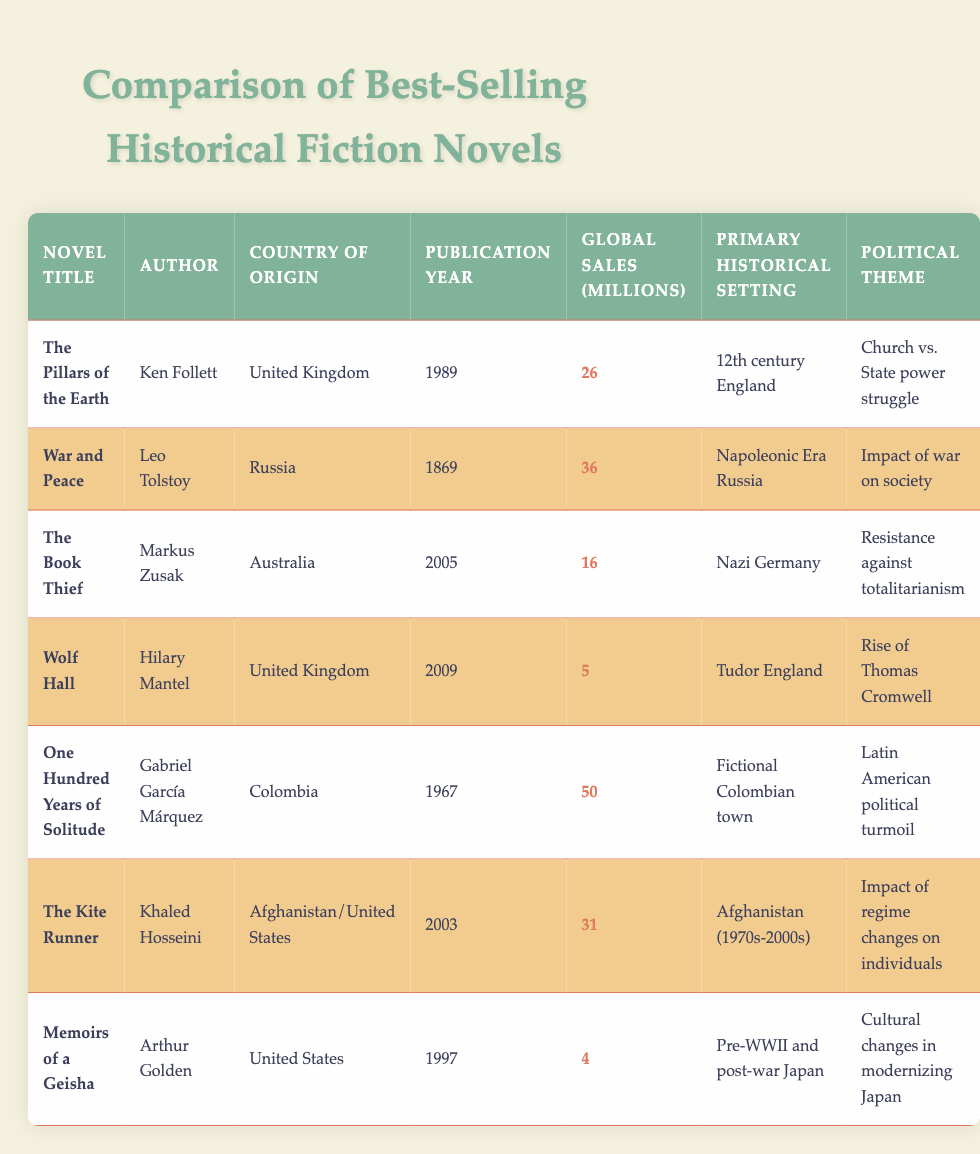What is the title of the best-selling historical fiction novel that has the highest global sales? By looking at the "Global Sales (millions)" column, "One Hundred Years of Solitude" has the highest value of 50 million. Therefore, it has the highest global sales among the listed novels.
Answer: One Hundred Years of Solitude Which novel was published most recently and what year was it published? The most recently published novel is "Wolf Hall," which was published in 2009. This can be determined by comparing the "Publication Year" column.
Answer: 2009 Is "The Kite Runner" from the United States? "The Kite Runner" is listed as authored by Khaled Hosseini, who is from Afghanistan and the United States. This means that it originates from both countries, making the statement partially true.
Answer: Yes How many novels in the table have global sales of over 25 million? From the data, we check the "Global Sales (millions)" and find that "War and Peace" (36), "The Kite Runner" (31), and "One Hundred Years of Solitude" (50) have over 25 million sales. This gives us a total of 3 novels.
Answer: 3 What is the primary historical setting of "The Book Thief"? In the "Primary Historical Setting" column, "The Book Thief" is set in Nazi Germany. This can be directly found in the related row for this novel.
Answer: Nazi Germany Compare the publication year of "Memoirs of a Geisha" to "War and Peace". Which one was published earlier and by how many years? "Memoirs of a Geisha" was published in 1997, while "War and Peace" was published in 1869. To find out who was published earlier, we subtract 1869 from 1997, giving us a difference of 128 years.
Answer: War and Peace, 128 years Which author wrote a novel set in the Tudor England period, and what is the title of that novel? Looking at the "Primary Historical Setting" column, we find that "Wolf Hall" is set in Tudor England, written by author Hilary Mantel.
Answer: Wolf Hall, Hilary Mantel Is there a novel in this list that discusses the cultural changes in modernizing Japan? Yes, "Memoirs of a Geisha" addresses cultural changes in modernizing Japan, as stated in the "Political Theme" column. Therefore, the answer is affirmative.
Answer: Yes What average global sales (in millions) can be calculated for the novels originating from the United Kingdom? The novels from the United Kingdom are "The Pillars of the Earth" (26 million) and "Wolf Hall" (5 million). Their total sales are 26 + 5 = 31 million. Dividing by the 2 novels gives an average of 31 / 2 = 15.5 million.
Answer: 15.5 million 